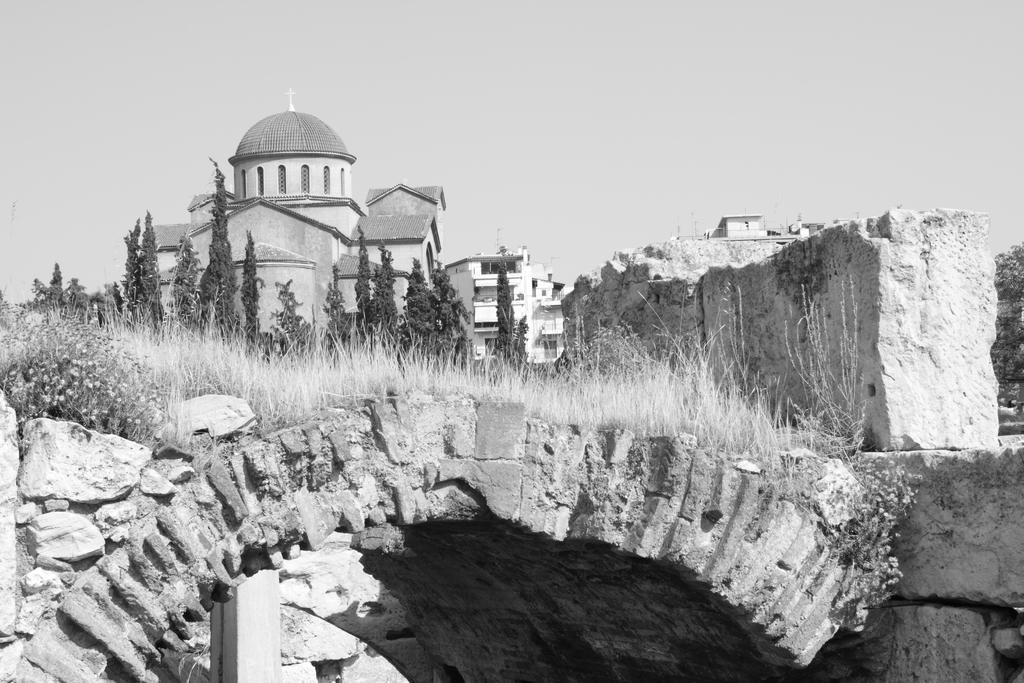In one or two sentences, can you explain what this image depicts? In this image we can see grass on the roof which is made of rocks. Behind trees and buildings are present. 